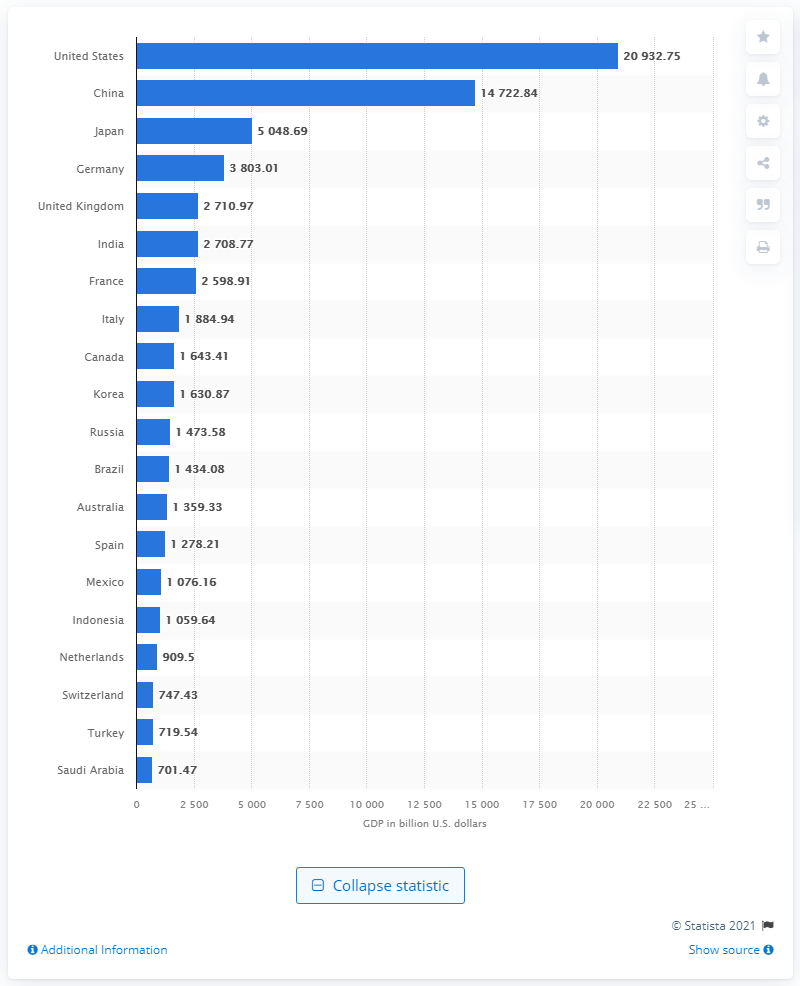Draw attention to some important aspects in this diagram. In 2020, Turkey's GDP was estimated to be approximately 719.54 billion dollars. 